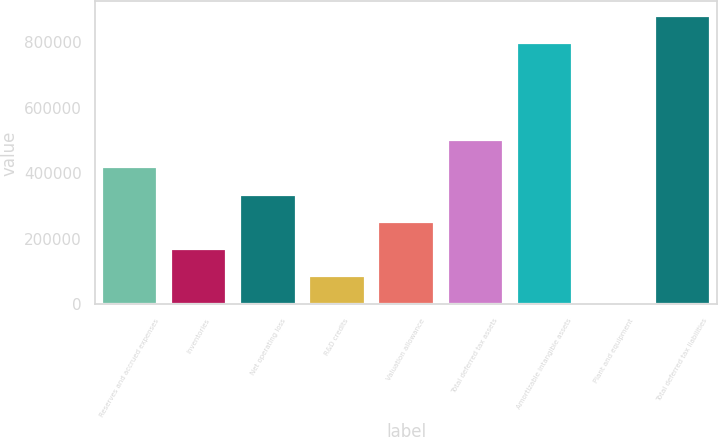Convert chart. <chart><loc_0><loc_0><loc_500><loc_500><bar_chart><fcel>Reserves and accrued expenses<fcel>Inventories<fcel>Net operating loss<fcel>R&D credits<fcel>Valuation allowance<fcel>Total deferred tax assets<fcel>Amortizable intangible assets<fcel>Plant and equipment<fcel>Total deferred tax liabilities<nl><fcel>417982<fcel>170038<fcel>335334<fcel>87389.3<fcel>252686<fcel>500631<fcel>798502<fcel>4741<fcel>881150<nl></chart> 